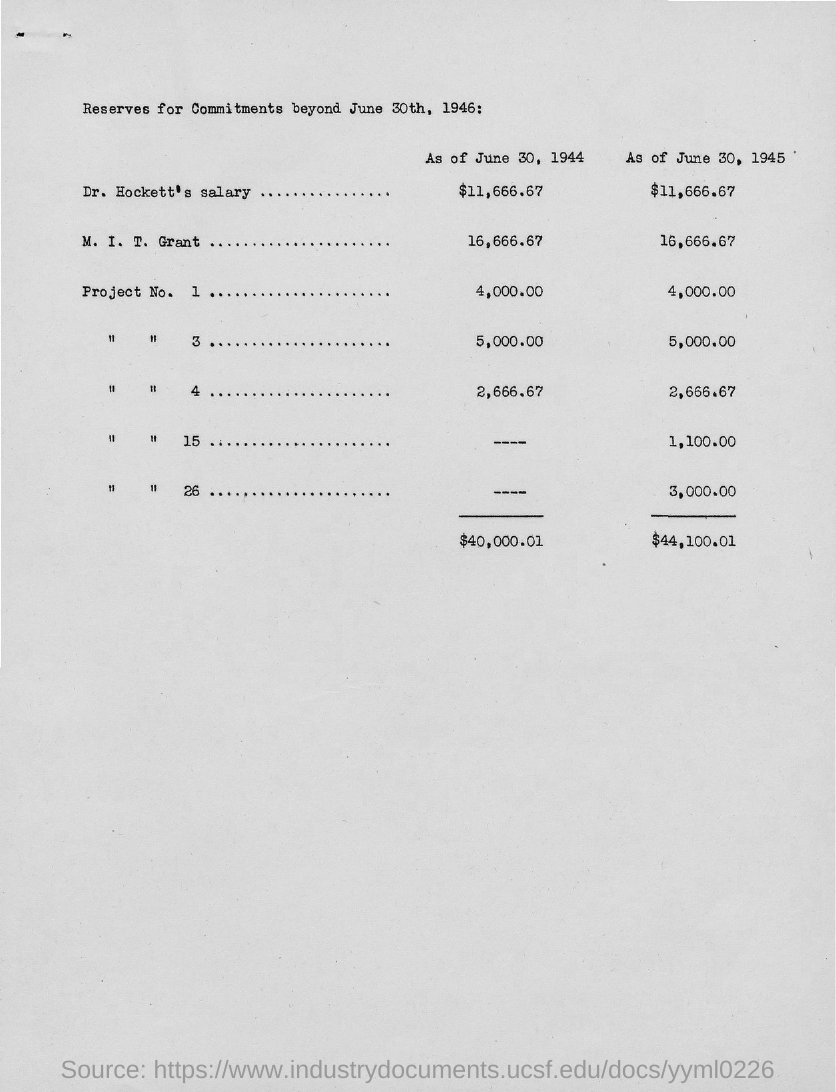Highlight a few significant elements in this photo. The M.I.T. Grant amount as of June 30, 1945, was $16,666.67. According to the records maintained by the Office of the Secretary of the Treasury, Dr. Hockett's salary as of June 30, 1945, was $11,666.67. As of June 30, 1944, Dr. Hockett's salary was $11,666.67. 